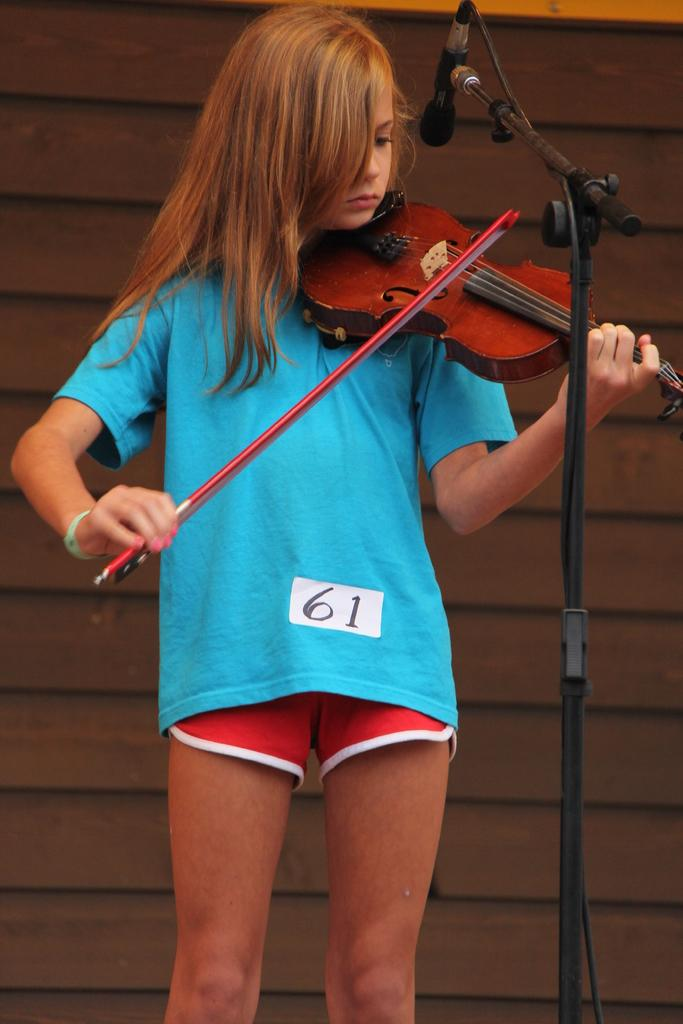What is the person in the image doing? The person is playing a guitar. What object is present in the image that is commonly used for amplifying sound? There is a microphone (mike) in the image. What type of insect can be seen crawling on the guitar strings in the image? There is no insect present in the image; it only shows a person playing a guitar and a microphone. 